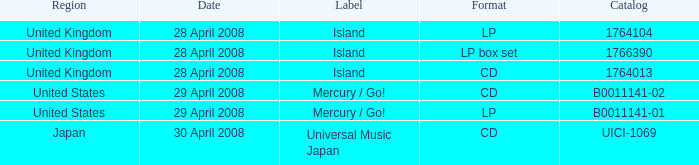What is the Label of the B0011141-01 Catalog? Mercury / Go!. Help me parse the entirety of this table. {'header': ['Region', 'Date', 'Label', 'Format', 'Catalog'], 'rows': [['United Kingdom', '28 April 2008', 'Island', 'LP', '1764104'], ['United Kingdom', '28 April 2008', 'Island', 'LP box set', '1766390'], ['United Kingdom', '28 April 2008', 'Island', 'CD', '1764013'], ['United States', '29 April 2008', 'Mercury / Go!', 'CD', 'B0011141-02'], ['United States', '29 April 2008', 'Mercury / Go!', 'LP', 'B0011141-01'], ['Japan', '30 April 2008', 'Universal Music Japan', 'CD', 'UICI-1069']]} 